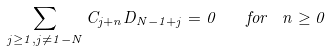Convert formula to latex. <formula><loc_0><loc_0><loc_500><loc_500>\sum _ { j \geq 1 , j \ne 1 - N } C _ { j + n } D _ { N - 1 + j } = 0 \quad { f o r } \ \ n \geq 0</formula> 